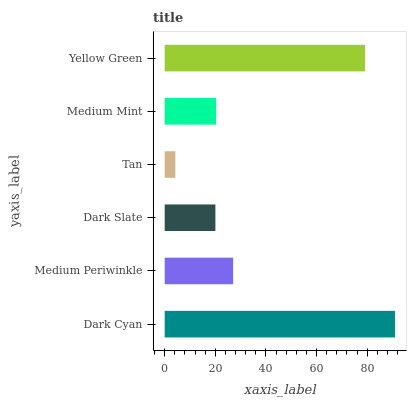Is Tan the minimum?
Answer yes or no. Yes. Is Dark Cyan the maximum?
Answer yes or no. Yes. Is Medium Periwinkle the minimum?
Answer yes or no. No. Is Medium Periwinkle the maximum?
Answer yes or no. No. Is Dark Cyan greater than Medium Periwinkle?
Answer yes or no. Yes. Is Medium Periwinkle less than Dark Cyan?
Answer yes or no. Yes. Is Medium Periwinkle greater than Dark Cyan?
Answer yes or no. No. Is Dark Cyan less than Medium Periwinkle?
Answer yes or no. No. Is Medium Periwinkle the high median?
Answer yes or no. Yes. Is Medium Mint the low median?
Answer yes or no. Yes. Is Dark Slate the high median?
Answer yes or no. No. Is Medium Periwinkle the low median?
Answer yes or no. No. 